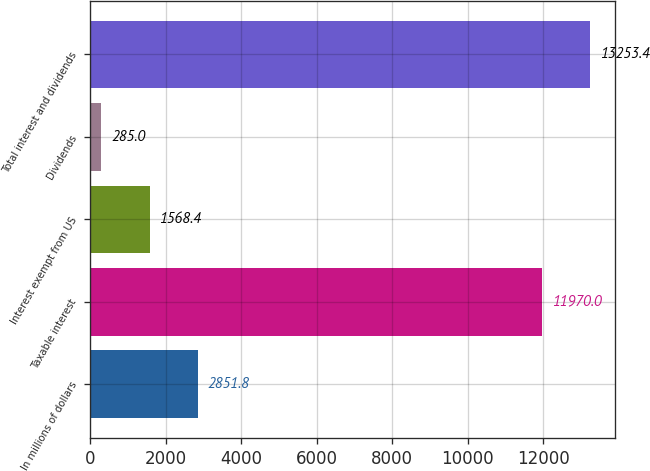Convert chart to OTSL. <chart><loc_0><loc_0><loc_500><loc_500><bar_chart><fcel>In millions of dollars<fcel>Taxable interest<fcel>Interest exempt from US<fcel>Dividends<fcel>Total interest and dividends<nl><fcel>2851.8<fcel>11970<fcel>1568.4<fcel>285<fcel>13253.4<nl></chart> 